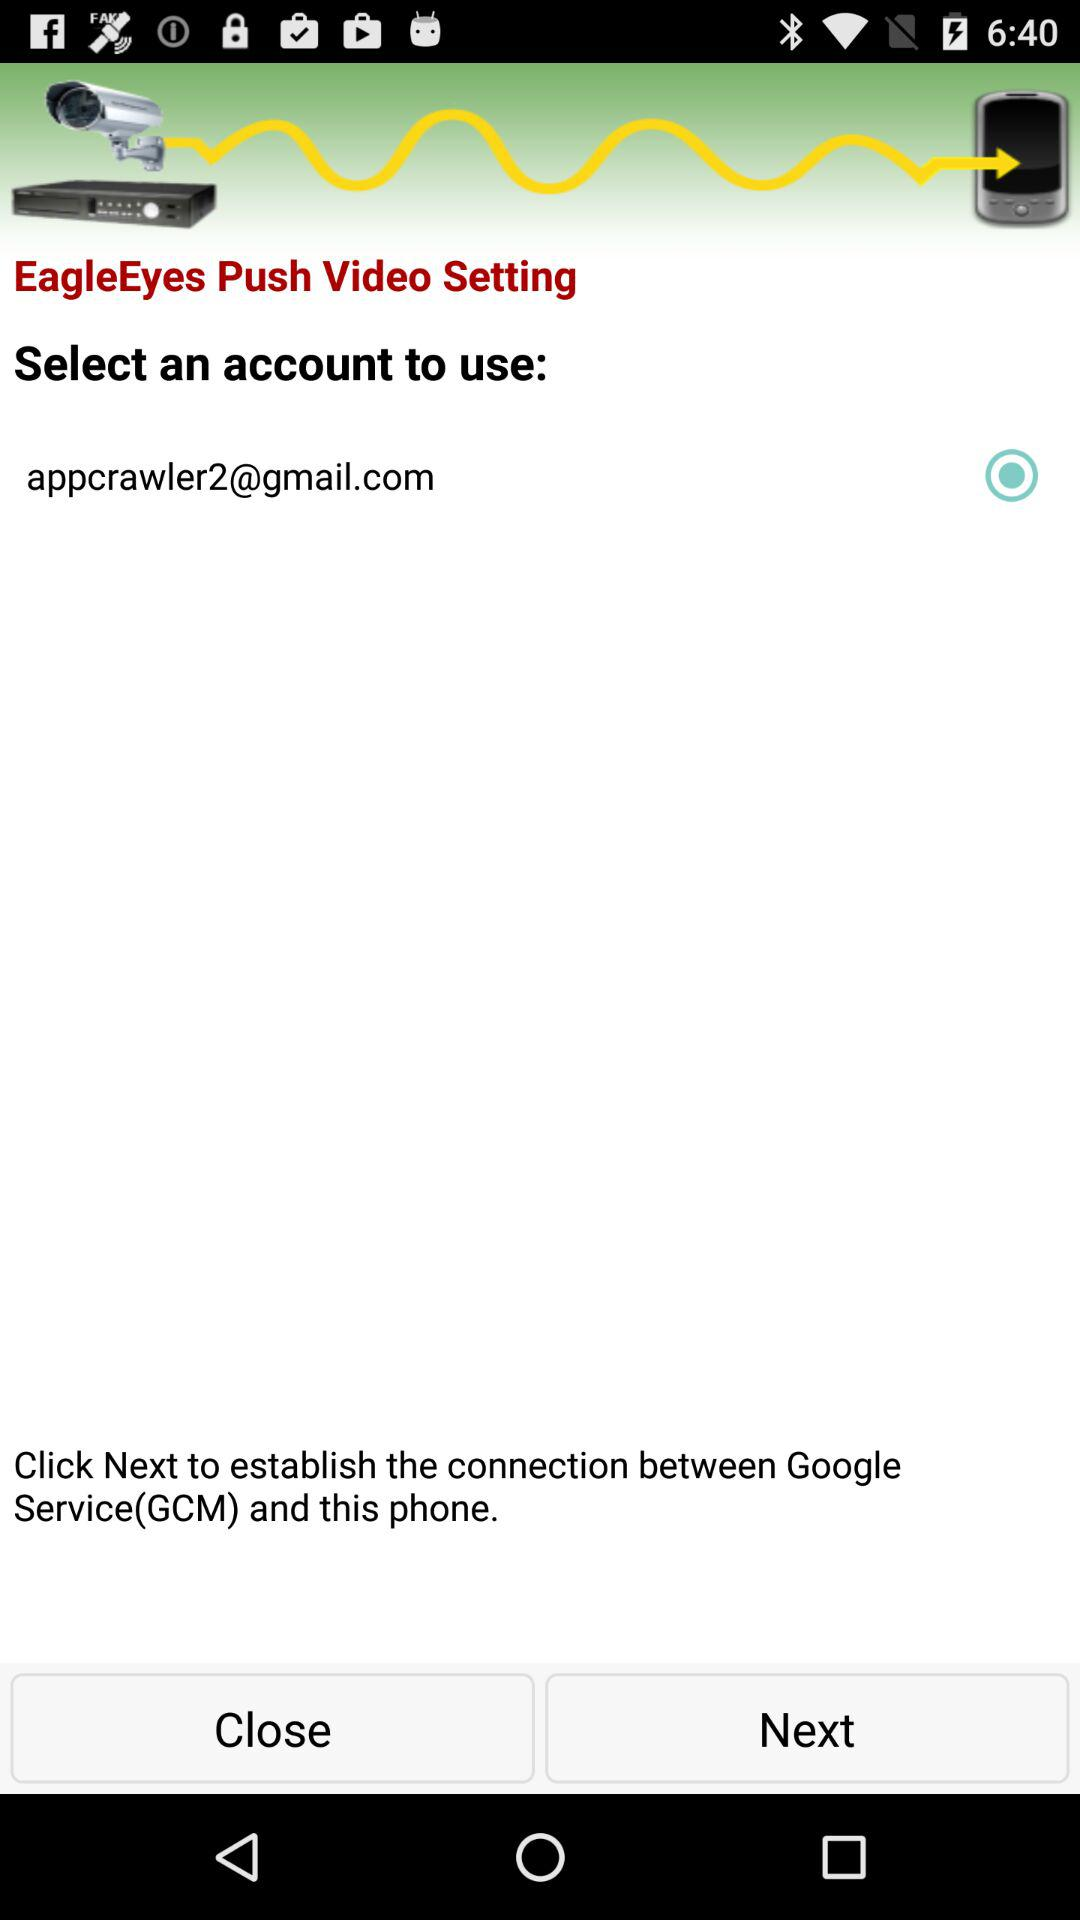How many actions are available on this screen?
Answer the question using a single word or phrase. 2 